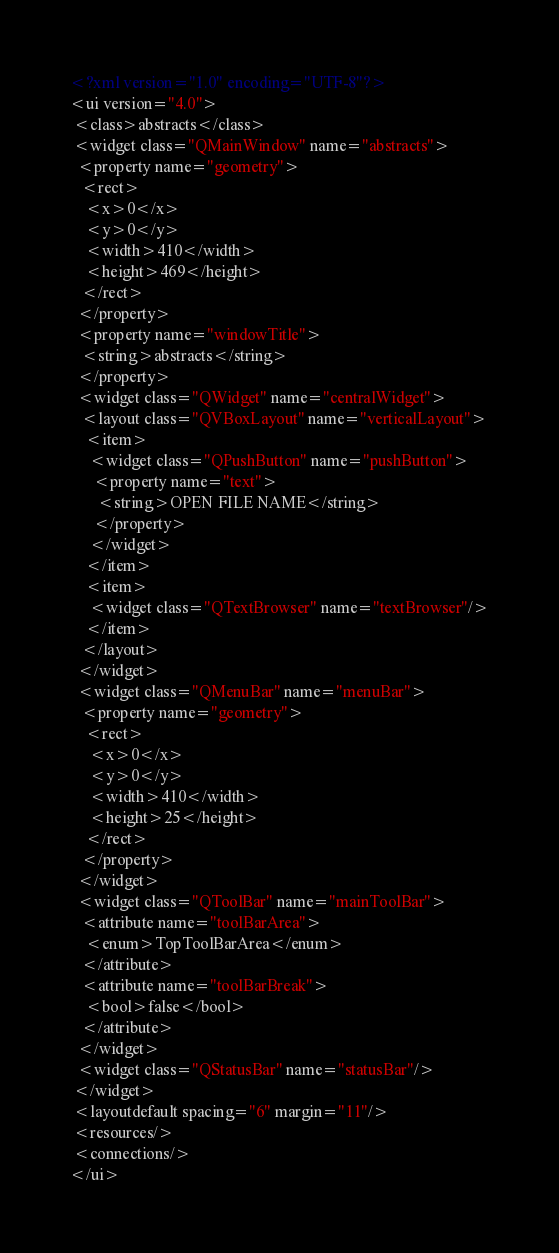<code> <loc_0><loc_0><loc_500><loc_500><_XML_><?xml version="1.0" encoding="UTF-8"?>
<ui version="4.0">
 <class>abstracts</class>
 <widget class="QMainWindow" name="abstracts">
  <property name="geometry">
   <rect>
    <x>0</x>
    <y>0</y>
    <width>410</width>
    <height>469</height>
   </rect>
  </property>
  <property name="windowTitle">
   <string>abstracts</string>
  </property>
  <widget class="QWidget" name="centralWidget">
   <layout class="QVBoxLayout" name="verticalLayout">
    <item>
     <widget class="QPushButton" name="pushButton">
      <property name="text">
       <string>OPEN FILE NAME</string>
      </property>
     </widget>
    </item>
    <item>
     <widget class="QTextBrowser" name="textBrowser"/>
    </item>
   </layout>
  </widget>
  <widget class="QMenuBar" name="menuBar">
   <property name="geometry">
    <rect>
     <x>0</x>
     <y>0</y>
     <width>410</width>
     <height>25</height>
    </rect>
   </property>
  </widget>
  <widget class="QToolBar" name="mainToolBar">
   <attribute name="toolBarArea">
    <enum>TopToolBarArea</enum>
   </attribute>
   <attribute name="toolBarBreak">
    <bool>false</bool>
   </attribute>
  </widget>
  <widget class="QStatusBar" name="statusBar"/>
 </widget>
 <layoutdefault spacing="6" margin="11"/>
 <resources/>
 <connections/>
</ui>
</code> 